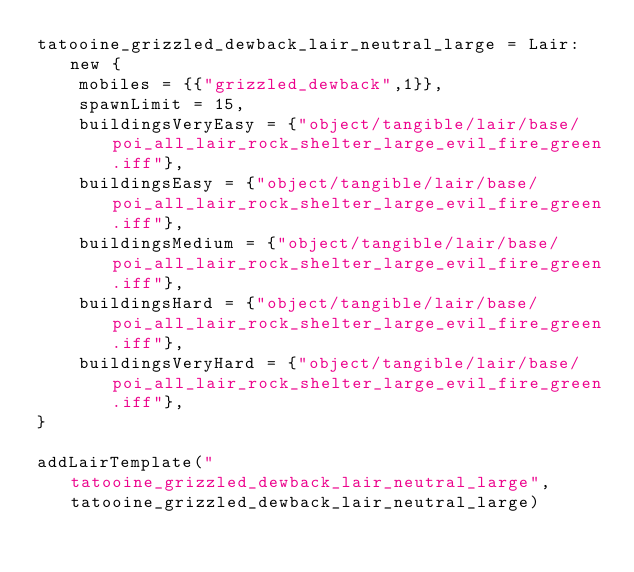Convert code to text. <code><loc_0><loc_0><loc_500><loc_500><_Lua_>tatooine_grizzled_dewback_lair_neutral_large = Lair:new {
	mobiles = {{"grizzled_dewback",1}},
	spawnLimit = 15,
	buildingsVeryEasy = {"object/tangible/lair/base/poi_all_lair_rock_shelter_large_evil_fire_green.iff"},
	buildingsEasy = {"object/tangible/lair/base/poi_all_lair_rock_shelter_large_evil_fire_green.iff"},
	buildingsMedium = {"object/tangible/lair/base/poi_all_lair_rock_shelter_large_evil_fire_green.iff"},
	buildingsHard = {"object/tangible/lair/base/poi_all_lair_rock_shelter_large_evil_fire_green.iff"},
	buildingsVeryHard = {"object/tangible/lair/base/poi_all_lair_rock_shelter_large_evil_fire_green.iff"},
}

addLairTemplate("tatooine_grizzled_dewback_lair_neutral_large", tatooine_grizzled_dewback_lair_neutral_large)
</code> 